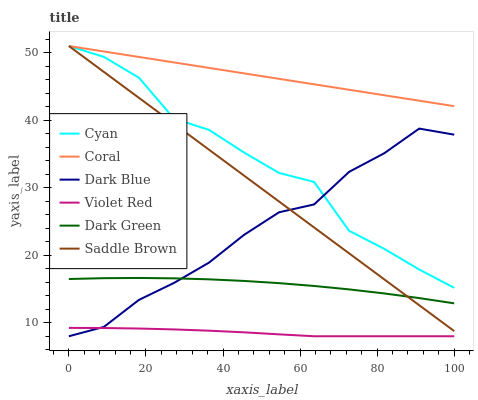Does Violet Red have the minimum area under the curve?
Answer yes or no. Yes. Does Coral have the maximum area under the curve?
Answer yes or no. Yes. Does Dark Blue have the minimum area under the curve?
Answer yes or no. No. Does Dark Blue have the maximum area under the curve?
Answer yes or no. No. Is Coral the smoothest?
Answer yes or no. Yes. Is Cyan the roughest?
Answer yes or no. Yes. Is Dark Blue the smoothest?
Answer yes or no. No. Is Dark Blue the roughest?
Answer yes or no. No. Does Violet Red have the lowest value?
Answer yes or no. Yes. Does Coral have the lowest value?
Answer yes or no. No. Does Saddle Brown have the highest value?
Answer yes or no. Yes. Does Dark Blue have the highest value?
Answer yes or no. No. Is Violet Red less than Dark Green?
Answer yes or no. Yes. Is Cyan greater than Dark Green?
Answer yes or no. Yes. Does Dark Blue intersect Cyan?
Answer yes or no. Yes. Is Dark Blue less than Cyan?
Answer yes or no. No. Is Dark Blue greater than Cyan?
Answer yes or no. No. Does Violet Red intersect Dark Green?
Answer yes or no. No. 